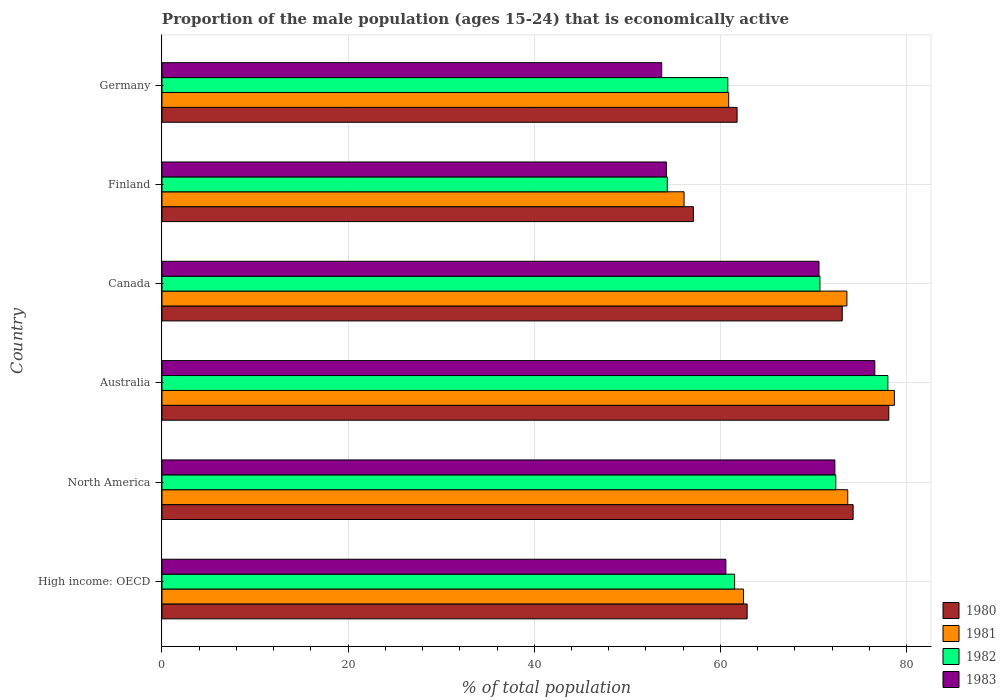How many different coloured bars are there?
Your response must be concise. 4. How many groups of bars are there?
Provide a short and direct response. 6. Are the number of bars per tick equal to the number of legend labels?
Your response must be concise. Yes. Are the number of bars on each tick of the Y-axis equal?
Your answer should be very brief. Yes. How many bars are there on the 3rd tick from the bottom?
Offer a very short reply. 4. In how many cases, is the number of bars for a given country not equal to the number of legend labels?
Keep it short and to the point. 0. What is the proportion of the male population that is economically active in 1981 in Germany?
Ensure brevity in your answer.  60.9. Across all countries, what is the maximum proportion of the male population that is economically active in 1982?
Your answer should be compact. 78. Across all countries, what is the minimum proportion of the male population that is economically active in 1980?
Give a very brief answer. 57.1. In which country was the proportion of the male population that is economically active in 1981 minimum?
Ensure brevity in your answer.  Finland. What is the total proportion of the male population that is economically active in 1980 in the graph?
Give a very brief answer. 407.25. What is the difference between the proportion of the male population that is economically active in 1983 in Australia and that in Germany?
Your response must be concise. 22.9. What is the difference between the proportion of the male population that is economically active in 1983 in North America and the proportion of the male population that is economically active in 1980 in Finland?
Your answer should be very brief. 15.21. What is the average proportion of the male population that is economically active in 1983 per country?
Ensure brevity in your answer.  64.67. What is the ratio of the proportion of the male population that is economically active in 1981 in Australia to that in North America?
Offer a terse response. 1.07. Is the difference between the proportion of the male population that is economically active in 1983 in Canada and Germany greater than the difference between the proportion of the male population that is economically active in 1980 in Canada and Germany?
Offer a terse response. Yes. What is the difference between the highest and the second highest proportion of the male population that is economically active in 1980?
Your response must be concise. 3.83. What is the difference between the highest and the lowest proportion of the male population that is economically active in 1981?
Your answer should be compact. 22.6. In how many countries, is the proportion of the male population that is economically active in 1983 greater than the average proportion of the male population that is economically active in 1983 taken over all countries?
Ensure brevity in your answer.  3. Is it the case that in every country, the sum of the proportion of the male population that is economically active in 1982 and proportion of the male population that is economically active in 1983 is greater than the sum of proportion of the male population that is economically active in 1980 and proportion of the male population that is economically active in 1981?
Offer a very short reply. No. Is it the case that in every country, the sum of the proportion of the male population that is economically active in 1981 and proportion of the male population that is economically active in 1982 is greater than the proportion of the male population that is economically active in 1983?
Provide a succinct answer. Yes. How many bars are there?
Offer a very short reply. 24. Are all the bars in the graph horizontal?
Your answer should be very brief. Yes. Are the values on the major ticks of X-axis written in scientific E-notation?
Your answer should be compact. No. Does the graph contain any zero values?
Offer a terse response. No. Does the graph contain grids?
Ensure brevity in your answer.  Yes. Where does the legend appear in the graph?
Give a very brief answer. Bottom right. How many legend labels are there?
Your answer should be compact. 4. How are the legend labels stacked?
Provide a succinct answer. Vertical. What is the title of the graph?
Provide a short and direct response. Proportion of the male population (ages 15-24) that is economically active. Does "2004" appear as one of the legend labels in the graph?
Your answer should be compact. No. What is the label or title of the X-axis?
Provide a short and direct response. % of total population. What is the % of total population of 1980 in High income: OECD?
Your response must be concise. 62.88. What is the % of total population of 1981 in High income: OECD?
Your answer should be compact. 62.49. What is the % of total population in 1982 in High income: OECD?
Provide a succinct answer. 61.53. What is the % of total population of 1983 in High income: OECD?
Keep it short and to the point. 60.59. What is the % of total population in 1980 in North America?
Make the answer very short. 74.27. What is the % of total population in 1981 in North America?
Your answer should be compact. 73.69. What is the % of total population in 1982 in North America?
Keep it short and to the point. 72.41. What is the % of total population in 1983 in North America?
Your response must be concise. 72.31. What is the % of total population in 1980 in Australia?
Ensure brevity in your answer.  78.1. What is the % of total population in 1981 in Australia?
Your answer should be very brief. 78.7. What is the % of total population in 1983 in Australia?
Keep it short and to the point. 76.6. What is the % of total population of 1980 in Canada?
Provide a short and direct response. 73.1. What is the % of total population of 1981 in Canada?
Make the answer very short. 73.6. What is the % of total population in 1982 in Canada?
Offer a very short reply. 70.7. What is the % of total population in 1983 in Canada?
Ensure brevity in your answer.  70.6. What is the % of total population in 1980 in Finland?
Give a very brief answer. 57.1. What is the % of total population of 1981 in Finland?
Keep it short and to the point. 56.1. What is the % of total population in 1982 in Finland?
Provide a succinct answer. 54.3. What is the % of total population in 1983 in Finland?
Offer a terse response. 54.2. What is the % of total population in 1980 in Germany?
Give a very brief answer. 61.8. What is the % of total population of 1981 in Germany?
Give a very brief answer. 60.9. What is the % of total population in 1982 in Germany?
Provide a succinct answer. 60.8. What is the % of total population in 1983 in Germany?
Your response must be concise. 53.7. Across all countries, what is the maximum % of total population in 1980?
Ensure brevity in your answer.  78.1. Across all countries, what is the maximum % of total population in 1981?
Your response must be concise. 78.7. Across all countries, what is the maximum % of total population of 1983?
Ensure brevity in your answer.  76.6. Across all countries, what is the minimum % of total population in 1980?
Offer a very short reply. 57.1. Across all countries, what is the minimum % of total population of 1981?
Provide a short and direct response. 56.1. Across all countries, what is the minimum % of total population in 1982?
Give a very brief answer. 54.3. Across all countries, what is the minimum % of total population of 1983?
Your answer should be very brief. 53.7. What is the total % of total population of 1980 in the graph?
Provide a short and direct response. 407.25. What is the total % of total population of 1981 in the graph?
Ensure brevity in your answer.  405.48. What is the total % of total population of 1982 in the graph?
Give a very brief answer. 397.74. What is the total % of total population in 1983 in the graph?
Offer a terse response. 388. What is the difference between the % of total population of 1980 in High income: OECD and that in North America?
Ensure brevity in your answer.  -11.39. What is the difference between the % of total population in 1981 in High income: OECD and that in North America?
Provide a succinct answer. -11.2. What is the difference between the % of total population in 1982 in High income: OECD and that in North America?
Offer a terse response. -10.87. What is the difference between the % of total population of 1983 in High income: OECD and that in North America?
Provide a succinct answer. -11.71. What is the difference between the % of total population of 1980 in High income: OECD and that in Australia?
Ensure brevity in your answer.  -15.22. What is the difference between the % of total population in 1981 in High income: OECD and that in Australia?
Offer a terse response. -16.21. What is the difference between the % of total population of 1982 in High income: OECD and that in Australia?
Provide a short and direct response. -16.47. What is the difference between the % of total population of 1983 in High income: OECD and that in Australia?
Provide a succinct answer. -16.01. What is the difference between the % of total population of 1980 in High income: OECD and that in Canada?
Your answer should be very brief. -10.22. What is the difference between the % of total population in 1981 in High income: OECD and that in Canada?
Provide a succinct answer. -11.11. What is the difference between the % of total population in 1982 in High income: OECD and that in Canada?
Give a very brief answer. -9.17. What is the difference between the % of total population of 1983 in High income: OECD and that in Canada?
Ensure brevity in your answer.  -10.01. What is the difference between the % of total population in 1980 in High income: OECD and that in Finland?
Your response must be concise. 5.78. What is the difference between the % of total population of 1981 in High income: OECD and that in Finland?
Your answer should be compact. 6.39. What is the difference between the % of total population in 1982 in High income: OECD and that in Finland?
Provide a succinct answer. 7.23. What is the difference between the % of total population of 1983 in High income: OECD and that in Finland?
Your answer should be compact. 6.39. What is the difference between the % of total population of 1980 in High income: OECD and that in Germany?
Your response must be concise. 1.08. What is the difference between the % of total population in 1981 in High income: OECD and that in Germany?
Your response must be concise. 1.59. What is the difference between the % of total population of 1982 in High income: OECD and that in Germany?
Provide a short and direct response. 0.73. What is the difference between the % of total population of 1983 in High income: OECD and that in Germany?
Keep it short and to the point. 6.89. What is the difference between the % of total population in 1980 in North America and that in Australia?
Give a very brief answer. -3.83. What is the difference between the % of total population in 1981 in North America and that in Australia?
Offer a very short reply. -5.01. What is the difference between the % of total population of 1982 in North America and that in Australia?
Provide a succinct answer. -5.59. What is the difference between the % of total population of 1983 in North America and that in Australia?
Your response must be concise. -4.29. What is the difference between the % of total population of 1980 in North America and that in Canada?
Provide a short and direct response. 1.17. What is the difference between the % of total population in 1981 in North America and that in Canada?
Provide a short and direct response. 0.09. What is the difference between the % of total population of 1982 in North America and that in Canada?
Offer a very short reply. 1.71. What is the difference between the % of total population of 1983 in North America and that in Canada?
Offer a very short reply. 1.71. What is the difference between the % of total population of 1980 in North America and that in Finland?
Offer a terse response. 17.17. What is the difference between the % of total population in 1981 in North America and that in Finland?
Your answer should be compact. 17.59. What is the difference between the % of total population in 1982 in North America and that in Finland?
Offer a terse response. 18.11. What is the difference between the % of total population of 1983 in North America and that in Finland?
Give a very brief answer. 18.11. What is the difference between the % of total population in 1980 in North America and that in Germany?
Your answer should be compact. 12.47. What is the difference between the % of total population of 1981 in North America and that in Germany?
Offer a terse response. 12.79. What is the difference between the % of total population in 1982 in North America and that in Germany?
Offer a very short reply. 11.61. What is the difference between the % of total population in 1983 in North America and that in Germany?
Your answer should be very brief. 18.61. What is the difference between the % of total population of 1980 in Australia and that in Canada?
Provide a short and direct response. 5. What is the difference between the % of total population in 1981 in Australia and that in Canada?
Offer a terse response. 5.1. What is the difference between the % of total population of 1982 in Australia and that in Canada?
Offer a very short reply. 7.3. What is the difference between the % of total population in 1983 in Australia and that in Canada?
Provide a short and direct response. 6. What is the difference between the % of total population in 1981 in Australia and that in Finland?
Your answer should be compact. 22.6. What is the difference between the % of total population of 1982 in Australia and that in Finland?
Keep it short and to the point. 23.7. What is the difference between the % of total population of 1983 in Australia and that in Finland?
Offer a very short reply. 22.4. What is the difference between the % of total population in 1980 in Australia and that in Germany?
Your answer should be very brief. 16.3. What is the difference between the % of total population in 1981 in Australia and that in Germany?
Offer a very short reply. 17.8. What is the difference between the % of total population of 1983 in Australia and that in Germany?
Your response must be concise. 22.9. What is the difference between the % of total population in 1980 in Canada and that in Finland?
Provide a short and direct response. 16. What is the difference between the % of total population of 1982 in Canada and that in Finland?
Give a very brief answer. 16.4. What is the difference between the % of total population in 1980 in Canada and that in Germany?
Your response must be concise. 11.3. What is the difference between the % of total population in 1981 in Canada and that in Germany?
Give a very brief answer. 12.7. What is the difference between the % of total population in 1982 in Canada and that in Germany?
Your answer should be very brief. 9.9. What is the difference between the % of total population in 1982 in Finland and that in Germany?
Provide a short and direct response. -6.5. What is the difference between the % of total population in 1980 in High income: OECD and the % of total population in 1981 in North America?
Offer a terse response. -10.81. What is the difference between the % of total population in 1980 in High income: OECD and the % of total population in 1982 in North America?
Keep it short and to the point. -9.53. What is the difference between the % of total population of 1980 in High income: OECD and the % of total population of 1983 in North America?
Offer a terse response. -9.43. What is the difference between the % of total population of 1981 in High income: OECD and the % of total population of 1982 in North America?
Offer a very short reply. -9.92. What is the difference between the % of total population of 1981 in High income: OECD and the % of total population of 1983 in North America?
Offer a terse response. -9.82. What is the difference between the % of total population of 1982 in High income: OECD and the % of total population of 1983 in North America?
Your response must be concise. -10.77. What is the difference between the % of total population in 1980 in High income: OECD and the % of total population in 1981 in Australia?
Offer a terse response. -15.82. What is the difference between the % of total population in 1980 in High income: OECD and the % of total population in 1982 in Australia?
Keep it short and to the point. -15.12. What is the difference between the % of total population of 1980 in High income: OECD and the % of total population of 1983 in Australia?
Keep it short and to the point. -13.72. What is the difference between the % of total population of 1981 in High income: OECD and the % of total population of 1982 in Australia?
Your response must be concise. -15.51. What is the difference between the % of total population of 1981 in High income: OECD and the % of total population of 1983 in Australia?
Your response must be concise. -14.11. What is the difference between the % of total population in 1982 in High income: OECD and the % of total population in 1983 in Australia?
Keep it short and to the point. -15.07. What is the difference between the % of total population in 1980 in High income: OECD and the % of total population in 1981 in Canada?
Provide a succinct answer. -10.72. What is the difference between the % of total population in 1980 in High income: OECD and the % of total population in 1982 in Canada?
Your answer should be very brief. -7.82. What is the difference between the % of total population of 1980 in High income: OECD and the % of total population of 1983 in Canada?
Provide a short and direct response. -7.72. What is the difference between the % of total population of 1981 in High income: OECD and the % of total population of 1982 in Canada?
Your answer should be very brief. -8.21. What is the difference between the % of total population of 1981 in High income: OECD and the % of total population of 1983 in Canada?
Provide a succinct answer. -8.11. What is the difference between the % of total population of 1982 in High income: OECD and the % of total population of 1983 in Canada?
Provide a succinct answer. -9.07. What is the difference between the % of total population of 1980 in High income: OECD and the % of total population of 1981 in Finland?
Ensure brevity in your answer.  6.78. What is the difference between the % of total population of 1980 in High income: OECD and the % of total population of 1982 in Finland?
Provide a succinct answer. 8.58. What is the difference between the % of total population of 1980 in High income: OECD and the % of total population of 1983 in Finland?
Keep it short and to the point. 8.68. What is the difference between the % of total population in 1981 in High income: OECD and the % of total population in 1982 in Finland?
Keep it short and to the point. 8.19. What is the difference between the % of total population of 1981 in High income: OECD and the % of total population of 1983 in Finland?
Your answer should be very brief. 8.29. What is the difference between the % of total population of 1982 in High income: OECD and the % of total population of 1983 in Finland?
Give a very brief answer. 7.33. What is the difference between the % of total population of 1980 in High income: OECD and the % of total population of 1981 in Germany?
Keep it short and to the point. 1.98. What is the difference between the % of total population of 1980 in High income: OECD and the % of total population of 1982 in Germany?
Provide a short and direct response. 2.08. What is the difference between the % of total population of 1980 in High income: OECD and the % of total population of 1983 in Germany?
Offer a terse response. 9.18. What is the difference between the % of total population of 1981 in High income: OECD and the % of total population of 1982 in Germany?
Give a very brief answer. 1.69. What is the difference between the % of total population of 1981 in High income: OECD and the % of total population of 1983 in Germany?
Provide a succinct answer. 8.79. What is the difference between the % of total population of 1982 in High income: OECD and the % of total population of 1983 in Germany?
Offer a terse response. 7.83. What is the difference between the % of total population of 1980 in North America and the % of total population of 1981 in Australia?
Offer a very short reply. -4.43. What is the difference between the % of total population in 1980 in North America and the % of total population in 1982 in Australia?
Offer a very short reply. -3.73. What is the difference between the % of total population in 1980 in North America and the % of total population in 1983 in Australia?
Offer a very short reply. -2.33. What is the difference between the % of total population of 1981 in North America and the % of total population of 1982 in Australia?
Your answer should be very brief. -4.31. What is the difference between the % of total population of 1981 in North America and the % of total population of 1983 in Australia?
Ensure brevity in your answer.  -2.91. What is the difference between the % of total population of 1982 in North America and the % of total population of 1983 in Australia?
Your answer should be compact. -4.19. What is the difference between the % of total population of 1980 in North America and the % of total population of 1981 in Canada?
Give a very brief answer. 0.67. What is the difference between the % of total population in 1980 in North America and the % of total population in 1982 in Canada?
Offer a terse response. 3.57. What is the difference between the % of total population of 1980 in North America and the % of total population of 1983 in Canada?
Make the answer very short. 3.67. What is the difference between the % of total population in 1981 in North America and the % of total population in 1982 in Canada?
Provide a succinct answer. 2.99. What is the difference between the % of total population in 1981 in North America and the % of total population in 1983 in Canada?
Offer a terse response. 3.09. What is the difference between the % of total population in 1982 in North America and the % of total population in 1983 in Canada?
Your answer should be compact. 1.81. What is the difference between the % of total population in 1980 in North America and the % of total population in 1981 in Finland?
Provide a short and direct response. 18.17. What is the difference between the % of total population in 1980 in North America and the % of total population in 1982 in Finland?
Provide a short and direct response. 19.97. What is the difference between the % of total population of 1980 in North America and the % of total population of 1983 in Finland?
Offer a very short reply. 20.07. What is the difference between the % of total population of 1981 in North America and the % of total population of 1982 in Finland?
Offer a very short reply. 19.39. What is the difference between the % of total population in 1981 in North America and the % of total population in 1983 in Finland?
Ensure brevity in your answer.  19.49. What is the difference between the % of total population in 1982 in North America and the % of total population in 1983 in Finland?
Your answer should be very brief. 18.21. What is the difference between the % of total population of 1980 in North America and the % of total population of 1981 in Germany?
Offer a very short reply. 13.37. What is the difference between the % of total population in 1980 in North America and the % of total population in 1982 in Germany?
Offer a very short reply. 13.47. What is the difference between the % of total population in 1980 in North America and the % of total population in 1983 in Germany?
Give a very brief answer. 20.57. What is the difference between the % of total population in 1981 in North America and the % of total population in 1982 in Germany?
Give a very brief answer. 12.89. What is the difference between the % of total population of 1981 in North America and the % of total population of 1983 in Germany?
Ensure brevity in your answer.  19.99. What is the difference between the % of total population in 1982 in North America and the % of total population in 1983 in Germany?
Your response must be concise. 18.71. What is the difference between the % of total population in 1980 in Australia and the % of total population in 1981 in Canada?
Offer a terse response. 4.5. What is the difference between the % of total population of 1980 in Australia and the % of total population of 1983 in Canada?
Give a very brief answer. 7.5. What is the difference between the % of total population in 1981 in Australia and the % of total population in 1983 in Canada?
Provide a short and direct response. 8.1. What is the difference between the % of total population in 1980 in Australia and the % of total population in 1982 in Finland?
Offer a terse response. 23.8. What is the difference between the % of total population in 1980 in Australia and the % of total population in 1983 in Finland?
Your answer should be compact. 23.9. What is the difference between the % of total population in 1981 in Australia and the % of total population in 1982 in Finland?
Keep it short and to the point. 24.4. What is the difference between the % of total population of 1981 in Australia and the % of total population of 1983 in Finland?
Keep it short and to the point. 24.5. What is the difference between the % of total population in 1982 in Australia and the % of total population in 1983 in Finland?
Ensure brevity in your answer.  23.8. What is the difference between the % of total population of 1980 in Australia and the % of total population of 1982 in Germany?
Offer a terse response. 17.3. What is the difference between the % of total population of 1980 in Australia and the % of total population of 1983 in Germany?
Your response must be concise. 24.4. What is the difference between the % of total population of 1981 in Australia and the % of total population of 1982 in Germany?
Your answer should be compact. 17.9. What is the difference between the % of total population of 1982 in Australia and the % of total population of 1983 in Germany?
Your answer should be compact. 24.3. What is the difference between the % of total population in 1980 in Canada and the % of total population in 1982 in Finland?
Ensure brevity in your answer.  18.8. What is the difference between the % of total population in 1981 in Canada and the % of total population in 1982 in Finland?
Keep it short and to the point. 19.3. What is the difference between the % of total population in 1981 in Canada and the % of total population in 1983 in Finland?
Ensure brevity in your answer.  19.4. What is the difference between the % of total population in 1980 in Canada and the % of total population in 1983 in Germany?
Offer a terse response. 19.4. What is the difference between the % of total population of 1981 in Canada and the % of total population of 1982 in Germany?
Your answer should be compact. 12.8. What is the difference between the % of total population in 1981 in Canada and the % of total population in 1983 in Germany?
Offer a very short reply. 19.9. What is the difference between the % of total population of 1981 in Finland and the % of total population of 1982 in Germany?
Provide a succinct answer. -4.7. What is the difference between the % of total population of 1981 in Finland and the % of total population of 1983 in Germany?
Your answer should be very brief. 2.4. What is the difference between the % of total population of 1982 in Finland and the % of total population of 1983 in Germany?
Provide a succinct answer. 0.6. What is the average % of total population in 1980 per country?
Provide a succinct answer. 67.87. What is the average % of total population in 1981 per country?
Provide a short and direct response. 67.58. What is the average % of total population of 1982 per country?
Make the answer very short. 66.29. What is the average % of total population in 1983 per country?
Keep it short and to the point. 64.67. What is the difference between the % of total population of 1980 and % of total population of 1981 in High income: OECD?
Offer a terse response. 0.39. What is the difference between the % of total population of 1980 and % of total population of 1982 in High income: OECD?
Offer a very short reply. 1.34. What is the difference between the % of total population of 1980 and % of total population of 1983 in High income: OECD?
Your answer should be very brief. 2.29. What is the difference between the % of total population of 1981 and % of total population of 1982 in High income: OECD?
Provide a short and direct response. 0.95. What is the difference between the % of total population of 1981 and % of total population of 1983 in High income: OECD?
Your answer should be compact. 1.89. What is the difference between the % of total population in 1982 and % of total population in 1983 in High income: OECD?
Your response must be concise. 0.94. What is the difference between the % of total population in 1980 and % of total population in 1981 in North America?
Keep it short and to the point. 0.58. What is the difference between the % of total population in 1980 and % of total population in 1982 in North America?
Provide a short and direct response. 1.86. What is the difference between the % of total population in 1980 and % of total population in 1983 in North America?
Offer a very short reply. 1.96. What is the difference between the % of total population in 1981 and % of total population in 1982 in North America?
Provide a short and direct response. 1.28. What is the difference between the % of total population in 1981 and % of total population in 1983 in North America?
Offer a very short reply. 1.38. What is the difference between the % of total population of 1982 and % of total population of 1983 in North America?
Give a very brief answer. 0.1. What is the difference between the % of total population of 1980 and % of total population of 1981 in Australia?
Keep it short and to the point. -0.6. What is the difference between the % of total population of 1981 and % of total population of 1982 in Australia?
Offer a very short reply. 0.7. What is the difference between the % of total population in 1982 and % of total population in 1983 in Australia?
Your response must be concise. 1.4. What is the difference between the % of total population of 1980 and % of total population of 1983 in Canada?
Keep it short and to the point. 2.5. What is the difference between the % of total population of 1981 and % of total population of 1982 in Canada?
Your answer should be compact. 2.9. What is the difference between the % of total population in 1982 and % of total population in 1983 in Canada?
Provide a succinct answer. 0.1. What is the difference between the % of total population of 1981 and % of total population of 1982 in Finland?
Ensure brevity in your answer.  1.8. What is the difference between the % of total population of 1980 and % of total population of 1981 in Germany?
Keep it short and to the point. 0.9. What is the difference between the % of total population of 1981 and % of total population of 1982 in Germany?
Your response must be concise. 0.1. What is the ratio of the % of total population in 1980 in High income: OECD to that in North America?
Keep it short and to the point. 0.85. What is the ratio of the % of total population in 1981 in High income: OECD to that in North America?
Offer a very short reply. 0.85. What is the ratio of the % of total population of 1982 in High income: OECD to that in North America?
Offer a terse response. 0.85. What is the ratio of the % of total population in 1983 in High income: OECD to that in North America?
Make the answer very short. 0.84. What is the ratio of the % of total population in 1980 in High income: OECD to that in Australia?
Make the answer very short. 0.81. What is the ratio of the % of total population in 1981 in High income: OECD to that in Australia?
Keep it short and to the point. 0.79. What is the ratio of the % of total population in 1982 in High income: OECD to that in Australia?
Your response must be concise. 0.79. What is the ratio of the % of total population in 1983 in High income: OECD to that in Australia?
Offer a very short reply. 0.79. What is the ratio of the % of total population in 1980 in High income: OECD to that in Canada?
Keep it short and to the point. 0.86. What is the ratio of the % of total population of 1981 in High income: OECD to that in Canada?
Your answer should be compact. 0.85. What is the ratio of the % of total population of 1982 in High income: OECD to that in Canada?
Provide a succinct answer. 0.87. What is the ratio of the % of total population of 1983 in High income: OECD to that in Canada?
Keep it short and to the point. 0.86. What is the ratio of the % of total population in 1980 in High income: OECD to that in Finland?
Your answer should be very brief. 1.1. What is the ratio of the % of total population of 1981 in High income: OECD to that in Finland?
Provide a short and direct response. 1.11. What is the ratio of the % of total population of 1982 in High income: OECD to that in Finland?
Your answer should be compact. 1.13. What is the ratio of the % of total population of 1983 in High income: OECD to that in Finland?
Keep it short and to the point. 1.12. What is the ratio of the % of total population of 1980 in High income: OECD to that in Germany?
Your answer should be compact. 1.02. What is the ratio of the % of total population in 1981 in High income: OECD to that in Germany?
Ensure brevity in your answer.  1.03. What is the ratio of the % of total population in 1982 in High income: OECD to that in Germany?
Your answer should be compact. 1.01. What is the ratio of the % of total population in 1983 in High income: OECD to that in Germany?
Ensure brevity in your answer.  1.13. What is the ratio of the % of total population of 1980 in North America to that in Australia?
Offer a very short reply. 0.95. What is the ratio of the % of total population in 1981 in North America to that in Australia?
Provide a succinct answer. 0.94. What is the ratio of the % of total population of 1982 in North America to that in Australia?
Ensure brevity in your answer.  0.93. What is the ratio of the % of total population in 1983 in North America to that in Australia?
Ensure brevity in your answer.  0.94. What is the ratio of the % of total population of 1982 in North America to that in Canada?
Offer a very short reply. 1.02. What is the ratio of the % of total population in 1983 in North America to that in Canada?
Offer a very short reply. 1.02. What is the ratio of the % of total population in 1980 in North America to that in Finland?
Your response must be concise. 1.3. What is the ratio of the % of total population in 1981 in North America to that in Finland?
Your response must be concise. 1.31. What is the ratio of the % of total population in 1982 in North America to that in Finland?
Offer a very short reply. 1.33. What is the ratio of the % of total population in 1983 in North America to that in Finland?
Offer a terse response. 1.33. What is the ratio of the % of total population of 1980 in North America to that in Germany?
Keep it short and to the point. 1.2. What is the ratio of the % of total population in 1981 in North America to that in Germany?
Give a very brief answer. 1.21. What is the ratio of the % of total population of 1982 in North America to that in Germany?
Ensure brevity in your answer.  1.19. What is the ratio of the % of total population in 1983 in North America to that in Germany?
Keep it short and to the point. 1.35. What is the ratio of the % of total population of 1980 in Australia to that in Canada?
Ensure brevity in your answer.  1.07. What is the ratio of the % of total population in 1981 in Australia to that in Canada?
Offer a terse response. 1.07. What is the ratio of the % of total population of 1982 in Australia to that in Canada?
Give a very brief answer. 1.1. What is the ratio of the % of total population of 1983 in Australia to that in Canada?
Give a very brief answer. 1.08. What is the ratio of the % of total population in 1980 in Australia to that in Finland?
Give a very brief answer. 1.37. What is the ratio of the % of total population in 1981 in Australia to that in Finland?
Offer a terse response. 1.4. What is the ratio of the % of total population in 1982 in Australia to that in Finland?
Keep it short and to the point. 1.44. What is the ratio of the % of total population in 1983 in Australia to that in Finland?
Offer a very short reply. 1.41. What is the ratio of the % of total population in 1980 in Australia to that in Germany?
Offer a very short reply. 1.26. What is the ratio of the % of total population in 1981 in Australia to that in Germany?
Your answer should be very brief. 1.29. What is the ratio of the % of total population in 1982 in Australia to that in Germany?
Your response must be concise. 1.28. What is the ratio of the % of total population in 1983 in Australia to that in Germany?
Provide a succinct answer. 1.43. What is the ratio of the % of total population of 1980 in Canada to that in Finland?
Keep it short and to the point. 1.28. What is the ratio of the % of total population in 1981 in Canada to that in Finland?
Your response must be concise. 1.31. What is the ratio of the % of total population of 1982 in Canada to that in Finland?
Provide a short and direct response. 1.3. What is the ratio of the % of total population in 1983 in Canada to that in Finland?
Offer a terse response. 1.3. What is the ratio of the % of total population in 1980 in Canada to that in Germany?
Keep it short and to the point. 1.18. What is the ratio of the % of total population of 1981 in Canada to that in Germany?
Keep it short and to the point. 1.21. What is the ratio of the % of total population of 1982 in Canada to that in Germany?
Your answer should be compact. 1.16. What is the ratio of the % of total population in 1983 in Canada to that in Germany?
Offer a terse response. 1.31. What is the ratio of the % of total population in 1980 in Finland to that in Germany?
Provide a succinct answer. 0.92. What is the ratio of the % of total population in 1981 in Finland to that in Germany?
Keep it short and to the point. 0.92. What is the ratio of the % of total population in 1982 in Finland to that in Germany?
Provide a succinct answer. 0.89. What is the ratio of the % of total population in 1983 in Finland to that in Germany?
Ensure brevity in your answer.  1.01. What is the difference between the highest and the second highest % of total population in 1980?
Give a very brief answer. 3.83. What is the difference between the highest and the second highest % of total population in 1981?
Offer a terse response. 5.01. What is the difference between the highest and the second highest % of total population in 1982?
Your response must be concise. 5.59. What is the difference between the highest and the second highest % of total population in 1983?
Ensure brevity in your answer.  4.29. What is the difference between the highest and the lowest % of total population in 1981?
Your response must be concise. 22.6. What is the difference between the highest and the lowest % of total population of 1982?
Offer a very short reply. 23.7. What is the difference between the highest and the lowest % of total population of 1983?
Keep it short and to the point. 22.9. 